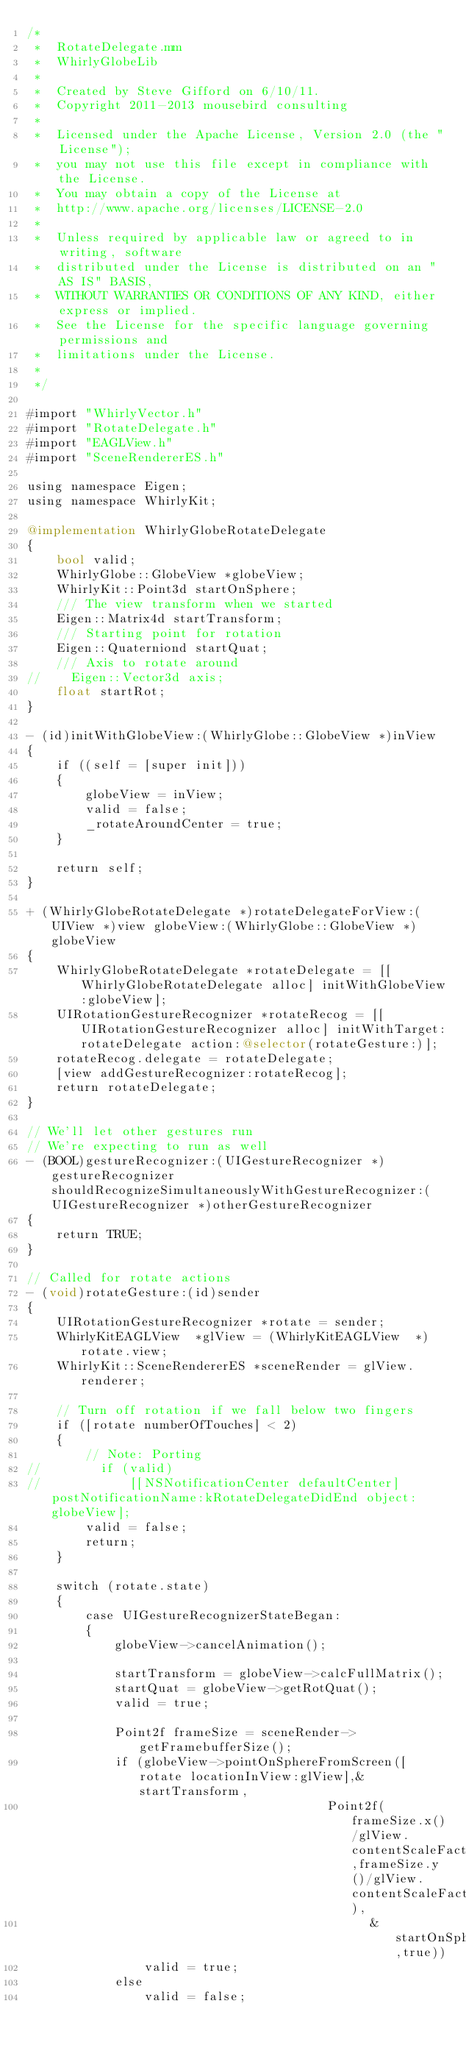<code> <loc_0><loc_0><loc_500><loc_500><_ObjectiveC_>/*
 *  RotateDelegate.mm
 *  WhirlyGlobeLib
 *
 *  Created by Steve Gifford on 6/10/11.
 *  Copyright 2011-2013 mousebird consulting
 *
 *  Licensed under the Apache License, Version 2.0 (the "License");
 *  you may not use this file except in compliance with the License.
 *  You may obtain a copy of the License at
 *  http://www.apache.org/licenses/LICENSE-2.0
 *
 *  Unless required by applicable law or agreed to in writing, software
 *  distributed under the License is distributed on an "AS IS" BASIS,
 *  WITHOUT WARRANTIES OR CONDITIONS OF ANY KIND, either express or implied.
 *  See the License for the specific language governing permissions and
 *  limitations under the License.
 *
 */

#import "WhirlyVector.h"
#import "RotateDelegate.h"
#import "EAGLView.h"
#import "SceneRendererES.h"

using namespace Eigen;
using namespace WhirlyKit;

@implementation WhirlyGlobeRotateDelegate
{
    bool valid;
    WhirlyGlobe::GlobeView *globeView;
	WhirlyKit::Point3d startOnSphere;
	/// The view transform when we started
	Eigen::Matrix4d startTransform;
    /// Starting point for rotation
    Eigen::Quaterniond startQuat;
    /// Axis to rotate around
//    Eigen::Vector3d axis;
    float startRot;
}

- (id)initWithGlobeView:(WhirlyGlobe::GlobeView *)inView
{
	if ((self = [super init]))
	{
		globeView = inView;
        valid = false;
        _rotateAroundCenter = true;
	}
	
	return self;
}

+ (WhirlyGlobeRotateDelegate *)rotateDelegateForView:(UIView *)view globeView:(WhirlyGlobe::GlobeView *)globeView
{
	WhirlyGlobeRotateDelegate *rotateDelegate = [[WhirlyGlobeRotateDelegate alloc] initWithGlobeView:globeView];
    UIRotationGestureRecognizer *rotateRecog = [[UIRotationGestureRecognizer alloc] initWithTarget:rotateDelegate action:@selector(rotateGesture:)];
    rotateRecog.delegate = rotateDelegate;
	[view addGestureRecognizer:rotateRecog];
	return rotateDelegate;
}

// We'll let other gestures run
// We're expecting to run as well
- (BOOL)gestureRecognizer:(UIGestureRecognizer *)gestureRecognizer shouldRecognizeSimultaneouslyWithGestureRecognizer:(UIGestureRecognizer *)otherGestureRecognizer
{
    return TRUE;
}

// Called for rotate actions
- (void)rotateGesture:(id)sender
{
	UIRotationGestureRecognizer *rotate = sender;
	WhirlyKitEAGLView  *glView = (WhirlyKitEAGLView  *)rotate.view;
	WhirlyKit::SceneRendererES *sceneRender = glView.renderer;
    
    // Turn off rotation if we fall below two fingers
    if ([rotate numberOfTouches] < 2)
    {
        // Note: Porting
//        if (valid)
//            [[NSNotificationCenter defaultCenter] postNotificationName:kRotateDelegateDidEnd object:globeView];
        valid = false;
        return;
    }
    
	switch (rotate.state)
	{
		case UIGestureRecognizerStateBegan:
        {
            globeView->cancelAnimation();

			startTransform = globeView->calcFullMatrix();
            startQuat = globeView->getRotQuat();
            valid = true;
            
            Point2f frameSize = sceneRender->getFramebufferSize();
            if (globeView->pointOnSphereFromScreen([rotate locationInView:glView],&startTransform,
                                         Point2f(frameSize.x()/glView.contentScaleFactor,frameSize.y()/glView.contentScaleFactor),
                                               &startOnSphere,true))
                valid = true;
            else
                valid = false;
            </code> 